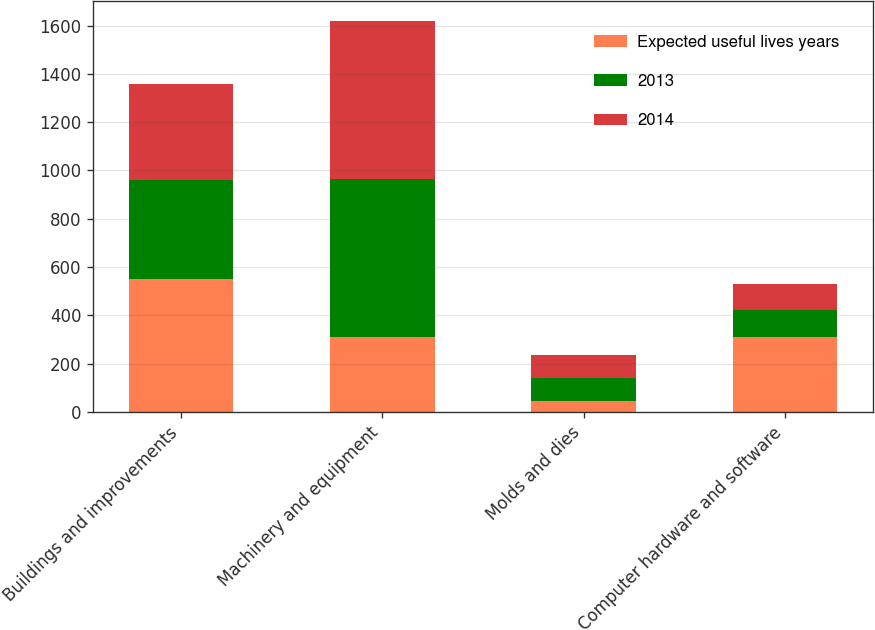Convert chart to OTSL. <chart><loc_0><loc_0><loc_500><loc_500><stacked_bar_chart><ecel><fcel>Buildings and improvements<fcel>Machinery and equipment<fcel>Molds and dies<fcel>Computer hardware and software<nl><fcel>Expected useful lives years<fcel>550<fcel>310<fcel>47<fcel>310<nl><fcel>2013<fcel>410.6<fcel>654.1<fcel>94.8<fcel>111.3<nl><fcel>2014<fcel>397.5<fcel>655.2<fcel>95.7<fcel>107.1<nl></chart> 